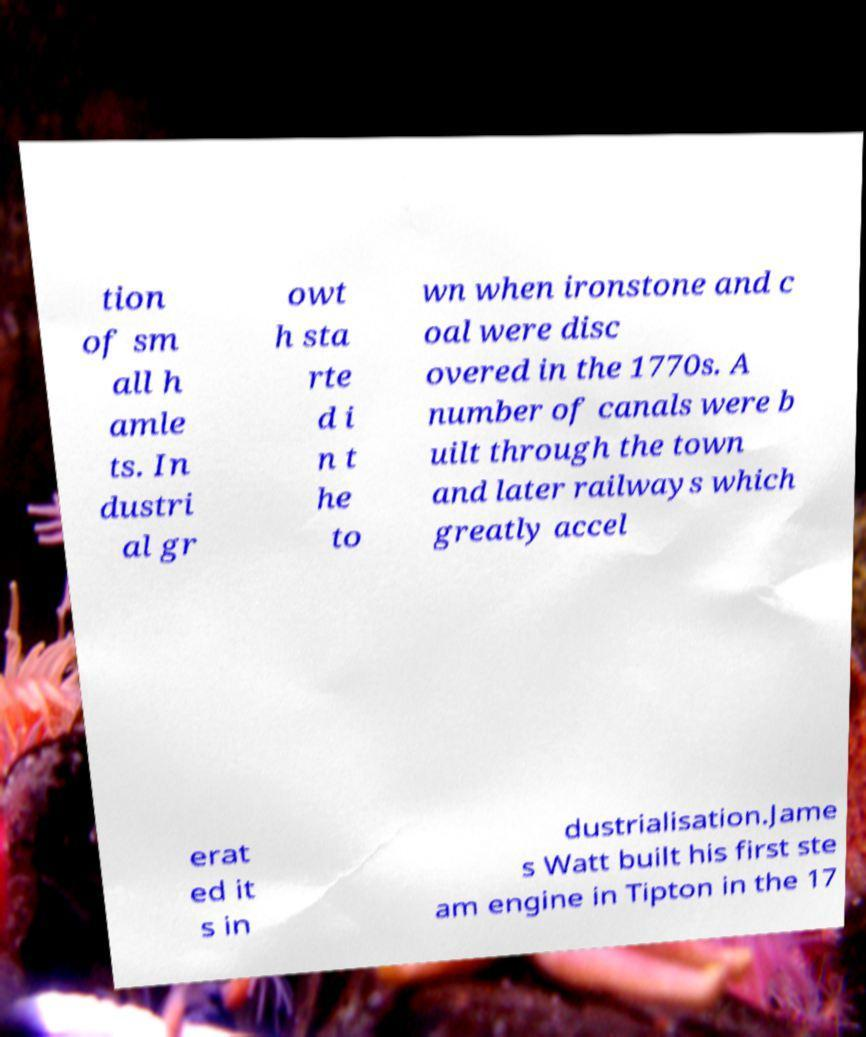Can you accurately transcribe the text from the provided image for me? tion of sm all h amle ts. In dustri al gr owt h sta rte d i n t he to wn when ironstone and c oal were disc overed in the 1770s. A number of canals were b uilt through the town and later railways which greatly accel erat ed it s in dustrialisation.Jame s Watt built his first ste am engine in Tipton in the 17 